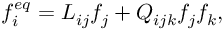<formula> <loc_0><loc_0><loc_500><loc_500>f _ { i } ^ { e q } = L _ { i j } f _ { j } + Q _ { i j k } f _ { j } f _ { k } ,</formula> 